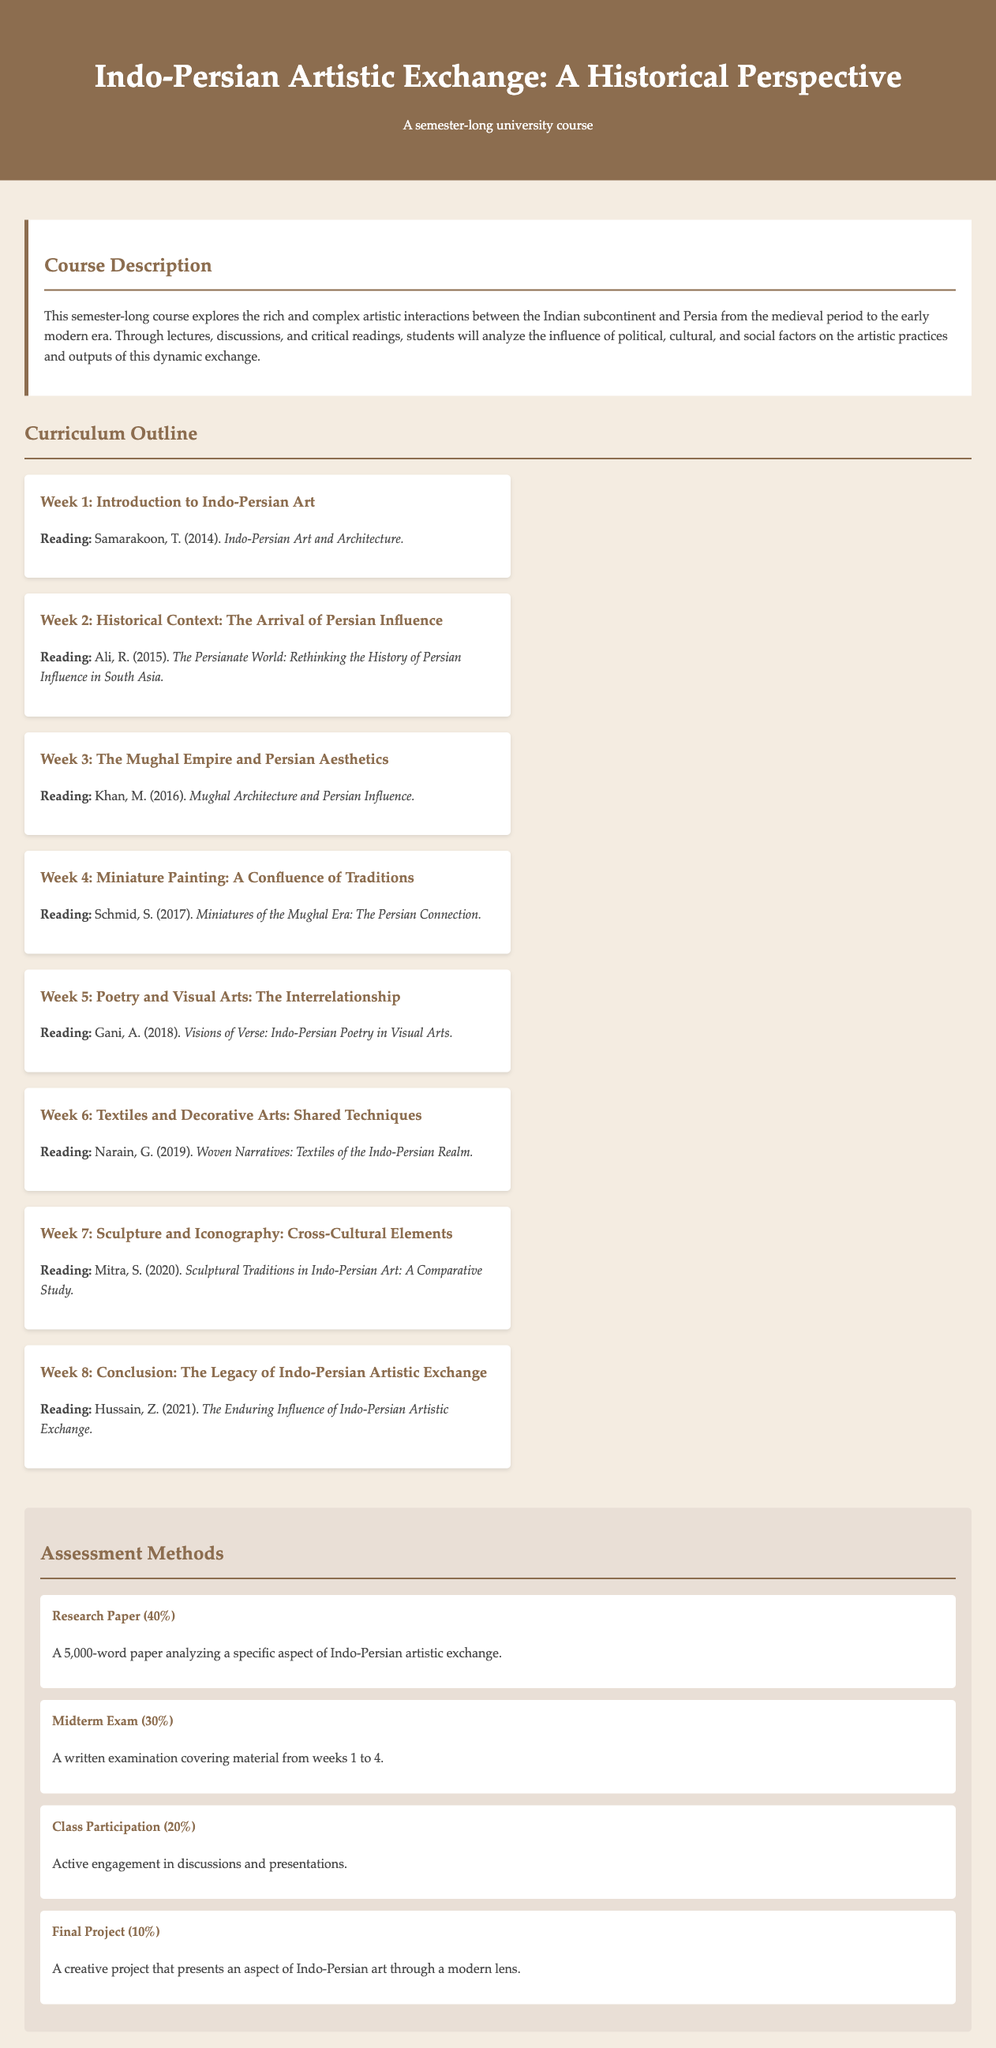What is the title of the course? The title is prominently displayed in the header of the document and is "Indo-Persian Artistic Exchange: A Historical Perspective."
Answer: Indo-Persian Artistic Exchange: A Historical Perspective How many weeks of curriculum are outlined in the document? The document lists eight weeks of curriculum under the "Curriculum Outline" section.
Answer: 8 Which reading is assigned for Week 4? The document specifies the reading assignment for Week 4, which is Schmid, S. (2017). Miniatures of the Mughal Era: The Persian Connection.
Answer: Schmid, S. (2017). Miniatures of the Mughal Era: The Persian Connection What percentage of the total grade does the research paper account for? The assessment section of the document clearly states that the research paper contributes 40% of the total grade.
Answer: 40% What is the final project percentage in the assessment methods? The document outlines that the final project contributes 10% to the overall assessment.
Answer: 10% Who is the author of the reading material for Week 3? The document states that the reading for Week 3 is by Khan, M. (2016).
Answer: Khan, M What is the focus of the course based on the course description? The course description emphasizes the exploration of "artistic interactions between the Indian subcontinent and Persia."
Answer: Artistic interactions between the Indian subcontinent and Persia What type of assessment is emphasized in the class participation component? The class participation assessment emphasizes "active engagement in discussions and presentations."
Answer: Active engagement in discussions and presentations 